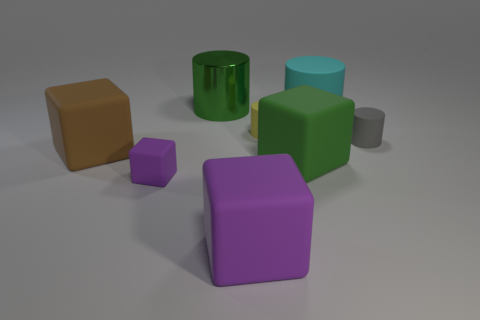What size is the other thing that is the same color as the big metallic thing?
Offer a terse response. Large. There is a purple matte thing that is on the right side of the tiny purple rubber cube; is its shape the same as the small gray thing?
Ensure brevity in your answer.  No. How many things are either large matte objects left of the green block or tiny purple cubes?
Provide a succinct answer. 3. The other small matte thing that is the same shape as the yellow matte object is what color?
Keep it short and to the point. Gray. Is there any other thing of the same color as the big matte cylinder?
Offer a terse response. No. What size is the purple object that is right of the metallic cylinder?
Provide a short and direct response. Large. There is a small matte cube; does it have the same color as the large thing that is in front of the small purple block?
Offer a terse response. Yes. How many other objects are the same material as the large cyan thing?
Keep it short and to the point. 6. Is the number of large rubber blocks greater than the number of brown objects?
Provide a short and direct response. Yes. Does the rubber cube that is right of the large purple rubber object have the same color as the large matte cylinder?
Make the answer very short. No. 